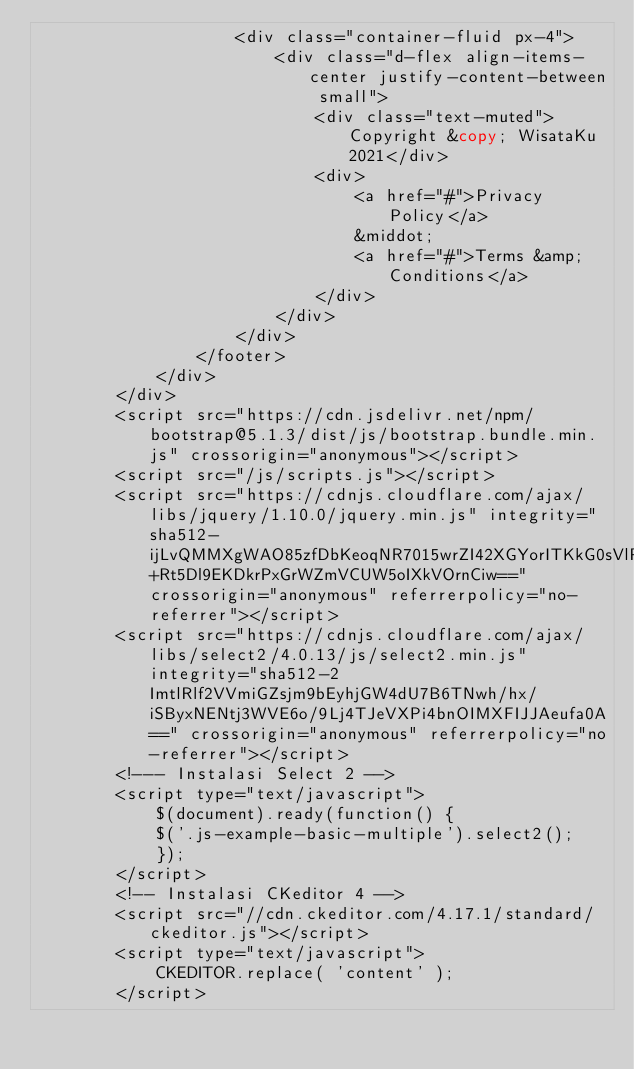<code> <loc_0><loc_0><loc_500><loc_500><_PHP_>                    <div class="container-fluid px-4">
                        <div class="d-flex align-items-center justify-content-between small">
                            <div class="text-muted">Copyright &copy; WisataKu 2021</div>
                            <div>
                                <a href="#">Privacy Policy</a>
                                &middot;
                                <a href="#">Terms &amp; Conditions</a>
                            </div>
                        </div>
                    </div>
                </footer>
            </div>
        </div>
        <script src="https://cdn.jsdelivr.net/npm/bootstrap@5.1.3/dist/js/bootstrap.bundle.min.js" crossorigin="anonymous"></script>
        <script src="/js/scripts.js"></script>
        <script src="https://cdnjs.cloudflare.com/ajax/libs/jquery/1.10.0/jquery.min.js" integrity="sha512-ijLvQMMXgWAO85zfDbKeoqNR7015wrZI42XGYorITKkG0sVlP4t+Rt5Dl9EKDkrPxGrWZmVCUW5oIXkVOrnCiw==" crossorigin="anonymous" referrerpolicy="no-referrer"></script>
        <script src="https://cdnjs.cloudflare.com/ajax/libs/select2/4.0.13/js/select2.min.js" integrity="sha512-2ImtlRlf2VVmiGZsjm9bEyhjGW4dU7B6TNwh/hx/iSByxNENtj3WVE6o/9Lj4TJeVXPi4bnOIMXFIJJAeufa0A==" crossorigin="anonymous" referrerpolicy="no-referrer"></script>
        <!--- Instalasi Select 2 -->
        <script type="text/javascript">
            $(document).ready(function() {
            $('.js-example-basic-multiple').select2();
            });
        </script>
        <!-- Instalasi CKeditor 4 -->
        <script src="//cdn.ckeditor.com/4.17.1/standard/ckeditor.js"></script>
        <script type="text/javascript">
            CKEDITOR.replace( 'content' );
        </script></code> 